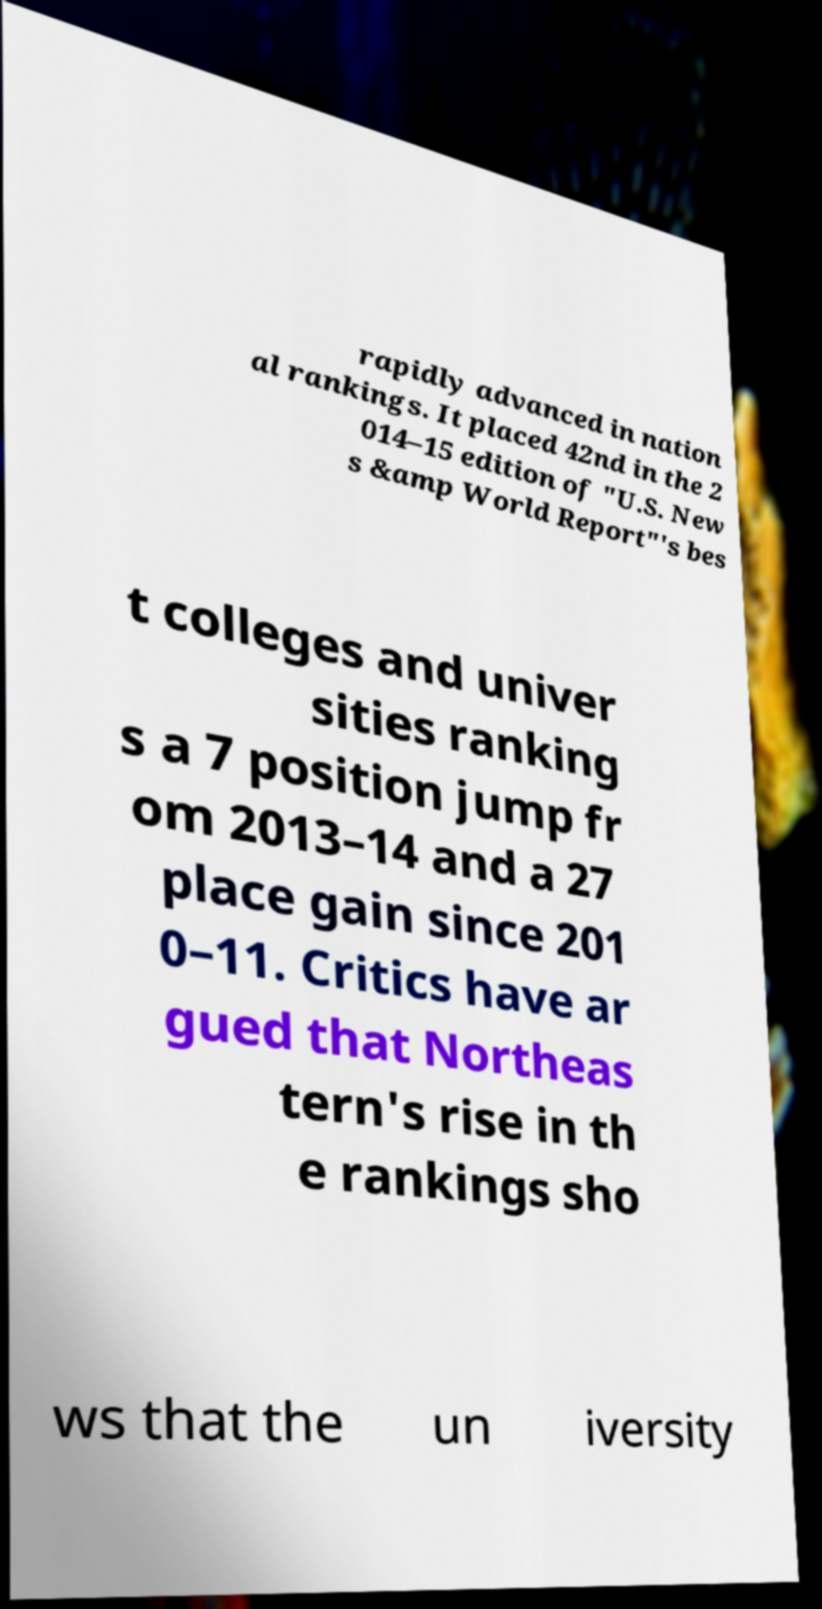Can you accurately transcribe the text from the provided image for me? rapidly advanced in nation al rankings. It placed 42nd in the 2 014–15 edition of "U.S. New s &amp World Report"'s bes t colleges and univer sities ranking s a 7 position jump fr om 2013–14 and a 27 place gain since 201 0–11. Critics have ar gued that Northeas tern's rise in th e rankings sho ws that the un iversity 